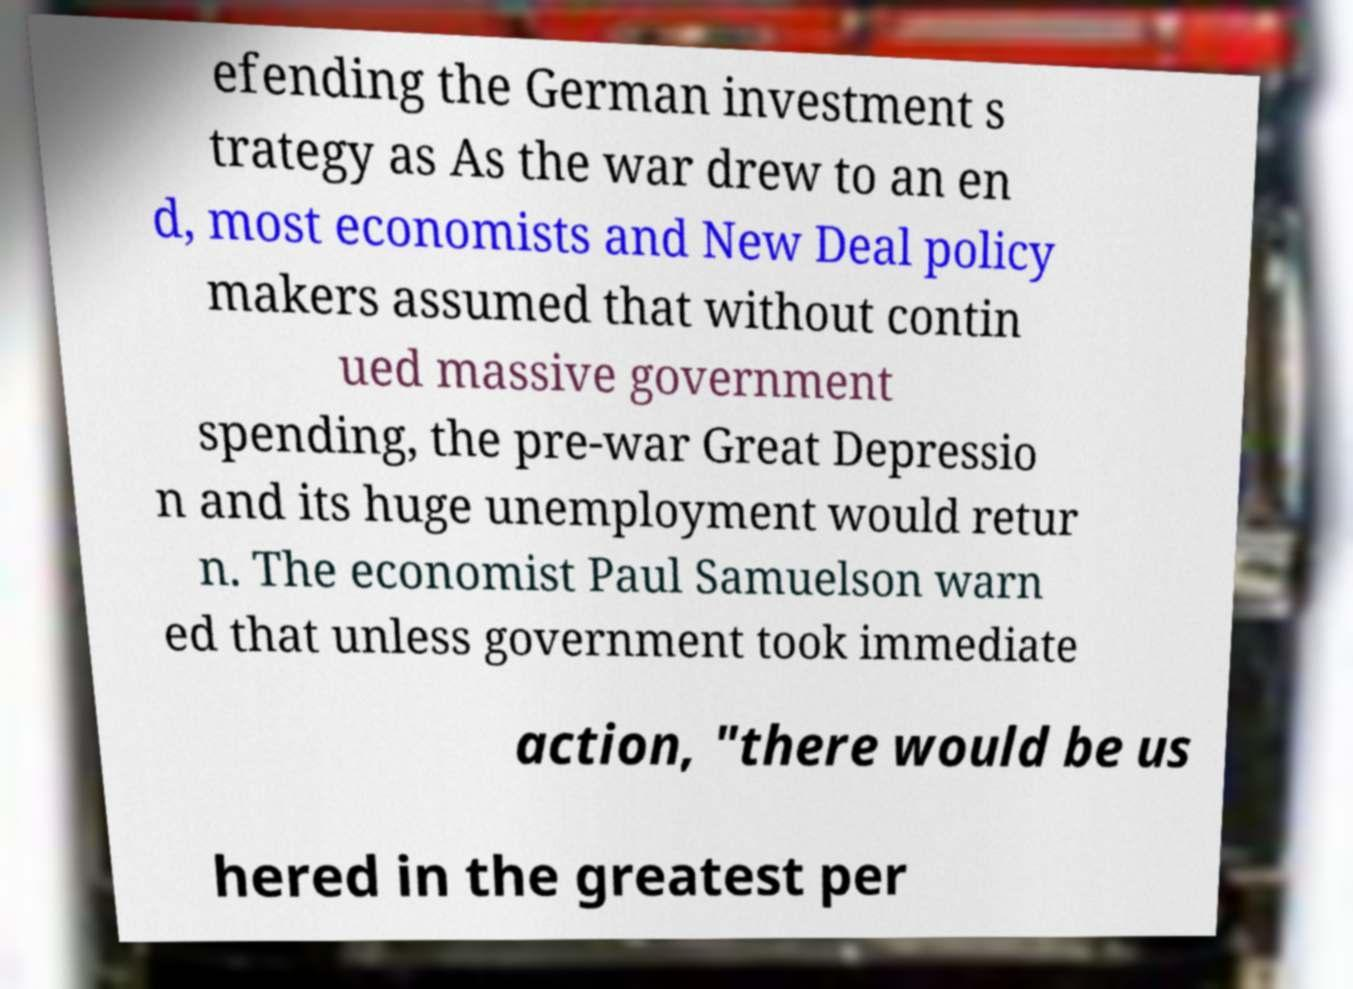Please identify and transcribe the text found in this image. efending the German investment s trategy as As the war drew to an en d, most economists and New Deal policy makers assumed that without contin ued massive government spending, the pre-war Great Depressio n and its huge unemployment would retur n. The economist Paul Samuelson warn ed that unless government took immediate action, "there would be us hered in the greatest per 